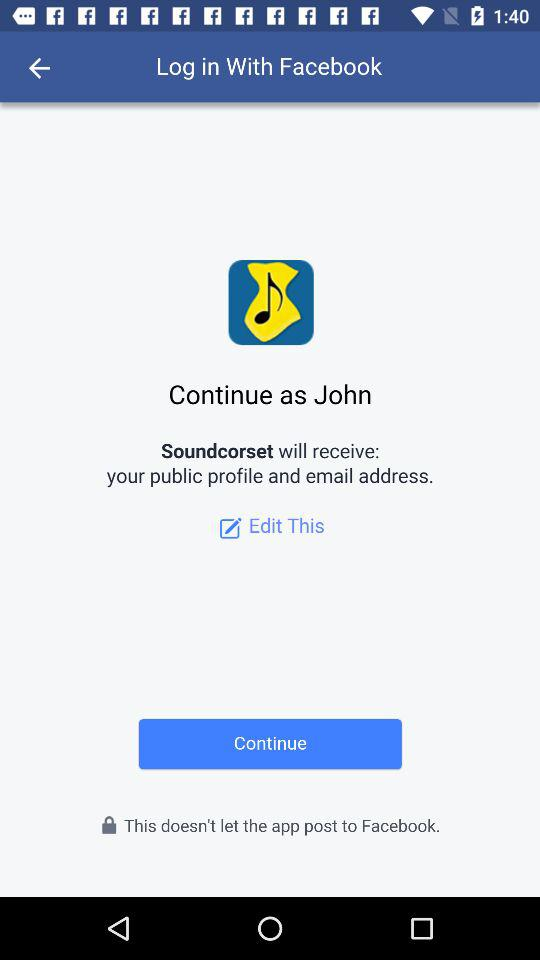What application will receive a public profile and email address? The application is "Soundcorset". 